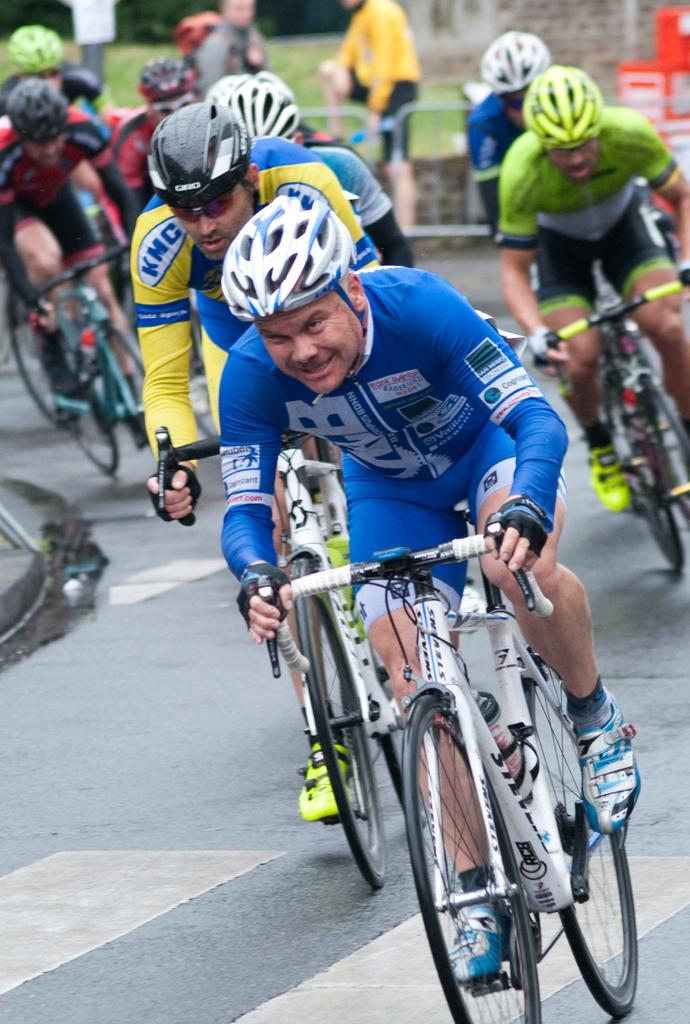Who or what can be seen in the image? There are people in the image. What are the people doing in the image? The people are riding bicycles. What safety precautions are the people taking while riding bicycles? The people are wearing helmets. What type of footwear are the people wearing in the image? The people are wearing shoes. What type of truck can be seen in the image? There is no truck present in the image; it features people riding bicycles. How does the activity of breathing affect the people in the image? The provided facts do not mention anything about the people's breathing, so it cannot be determined from the image. 